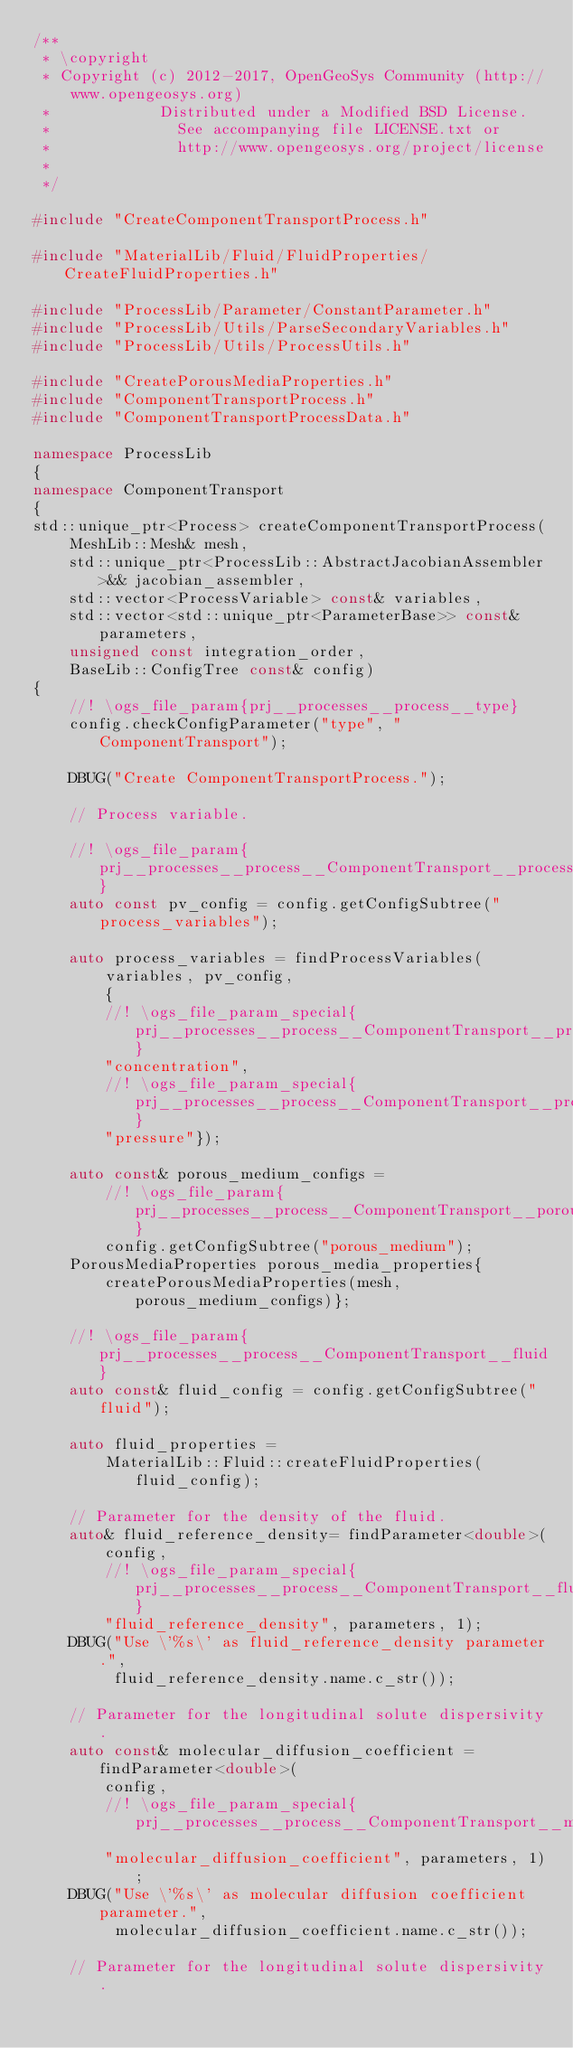<code> <loc_0><loc_0><loc_500><loc_500><_C++_>/**
 * \copyright
 * Copyright (c) 2012-2017, OpenGeoSys Community (http://www.opengeosys.org)
 *            Distributed under a Modified BSD License.
 *              See accompanying file LICENSE.txt or
 *              http://www.opengeosys.org/project/license
 *
 */

#include "CreateComponentTransportProcess.h"

#include "MaterialLib/Fluid/FluidProperties/CreateFluidProperties.h"

#include "ProcessLib/Parameter/ConstantParameter.h"
#include "ProcessLib/Utils/ParseSecondaryVariables.h"
#include "ProcessLib/Utils/ProcessUtils.h"

#include "CreatePorousMediaProperties.h"
#include "ComponentTransportProcess.h"
#include "ComponentTransportProcessData.h"

namespace ProcessLib
{
namespace ComponentTransport
{
std::unique_ptr<Process> createComponentTransportProcess(
    MeshLib::Mesh& mesh,
    std::unique_ptr<ProcessLib::AbstractJacobianAssembler>&& jacobian_assembler,
    std::vector<ProcessVariable> const& variables,
    std::vector<std::unique_ptr<ParameterBase>> const& parameters,
    unsigned const integration_order,
    BaseLib::ConfigTree const& config)
{
    //! \ogs_file_param{prj__processes__process__type}
    config.checkConfigParameter("type", "ComponentTransport");

    DBUG("Create ComponentTransportProcess.");

    // Process variable.

    //! \ogs_file_param{prj__processes__process__ComponentTransport__process_variables}
    auto const pv_config = config.getConfigSubtree("process_variables");

    auto process_variables = findProcessVariables(
        variables, pv_config,
        {
        //! \ogs_file_param_special{prj__processes__process__ComponentTransport__process_variables__concentration}
        "concentration",
        //! \ogs_file_param_special{prj__processes__process__ComponentTransport__process_variables__pressure}
        "pressure"});

    auto const& porous_medium_configs =
        //! \ogs_file_param{prj__processes__process__ComponentTransport__porous_medium}
        config.getConfigSubtree("porous_medium");
    PorousMediaProperties porous_media_properties{
        createPorousMediaProperties(mesh, porous_medium_configs)};

    //! \ogs_file_param{prj__processes__process__ComponentTransport__fluid}
    auto const& fluid_config = config.getConfigSubtree("fluid");

    auto fluid_properties =
        MaterialLib::Fluid::createFluidProperties(fluid_config);

    // Parameter for the density of the fluid.
    auto& fluid_reference_density= findParameter<double>(
        config,
        //! \ogs_file_param_special{prj__processes__process__ComponentTransport__fluid_reference_density}
        "fluid_reference_density", parameters, 1);
    DBUG("Use \'%s\' as fluid_reference_density parameter.",
         fluid_reference_density.name.c_str());

    // Parameter for the longitudinal solute dispersivity.
    auto const& molecular_diffusion_coefficient = findParameter<double>(
        config,
        //! \ogs_file_param_special{prj__processes__process__ComponentTransport__molecular_diffusion_coefficient
        "molecular_diffusion_coefficient", parameters, 1);
    DBUG("Use \'%s\' as molecular diffusion coefficient parameter.",
         molecular_diffusion_coefficient.name.c_str());

    // Parameter for the longitudinal solute dispersivity.</code> 